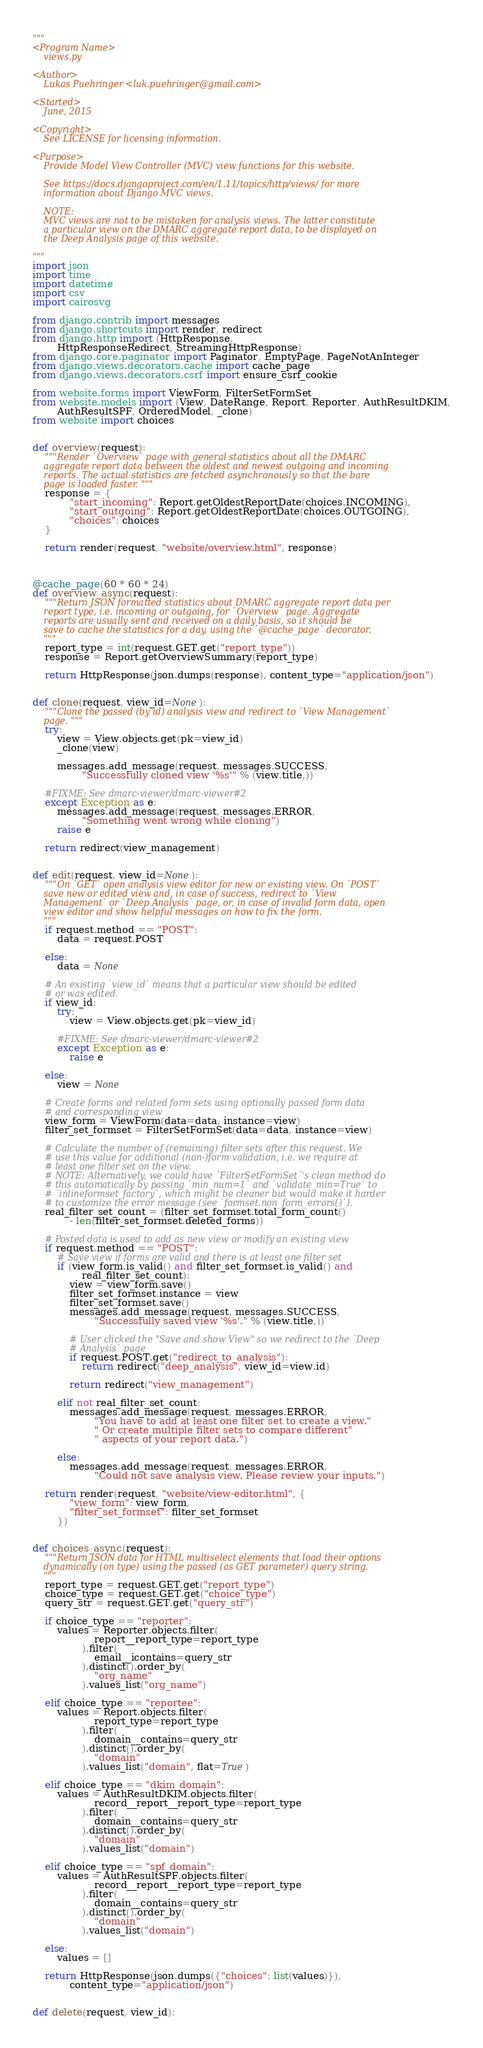<code> <loc_0><loc_0><loc_500><loc_500><_Python_>"""
<Program Name>
    views.py

<Author>
    Lukas Puehringer <luk.puehringer@gmail.com>

<Started>
    June, 2015

<Copyright>
    See LICENSE for licensing information.

<Purpose>
    Provide Model View Controller (MVC) view functions for this website.

    See https://docs.djangoproject.com/en/1.11/topics/http/views/ for more
    information about Django MVC views.

    NOTE:
    MVC views are not to be mistaken for analysis views. The latter constitute
    a particular view on the DMARC aggregate report data, to be displayed on
    the Deep Analysis page of this website.

"""
import json
import time
import datetime
import csv
import cairosvg

from django.contrib import messages
from django.shortcuts import render, redirect
from django.http import (HttpResponse,
        HttpResponseRedirect, StreamingHttpResponse)
from django.core.paginator import Paginator, EmptyPage, PageNotAnInteger
from django.views.decorators.cache import cache_page
from django.views.decorators.csrf import ensure_csrf_cookie

from website.forms import ViewForm, FilterSetFormSet
from website.models import (View, DateRange, Report, Reporter, AuthResultDKIM,
        AuthResultSPF, OrderedModel, _clone)
from website import choices


def overview(request):
    """Render `Overview` page with general statistics about all the DMARC
    aggregate report data between the oldest and newest outgoing and incoming
    reports. The actual statistics are fetched asynchronously so that the bare
    page is loaded faster. """
    response = {
            "start_incoming": Report.getOldestReportDate(choices.INCOMING),
            "start_outgoing": Report.getOldestReportDate(choices.OUTGOING),
            "choices": choices
    }

    return render(request, "website/overview.html", response)



@cache_page(60 * 60 * 24)
def overview_async(request):
    """Return JSON formatted statistics about DMARC aggregate report data per
    report type, i.e. incoming or outgoing, for `Overview` page. Aggregate
    reports are usually sent and received on a daily basis, so it should be
    save to cache the statistics for a day, using the `@cache_page` decorator.
    """
    report_type = int(request.GET.get("report_type"))
    response = Report.getOverviewSummary(report_type)

    return HttpResponse(json.dumps(response), content_type="application/json")


def clone(request, view_id=None):
    """Clone the passed (by id) analysis view and redirect to `View Management`
    page. """
    try:
        view = View.objects.get(pk=view_id)
        _clone(view)

        messages.add_message(request, messages.SUCCESS,
                "Successfully cloned view '%s'" % (view.title,))

    #FIXME: See dmarc-viewer/dmarc-viewer#2
    except Exception as e:
        messages.add_message(request, messages.ERROR,
                "Something went wrong while cloning")
        raise e

    return redirect(view_management)


def edit(request, view_id=None):
    """On `GET` open analysis view editor for new or existing view. On `POST`
    save new or edited view and, in case of success, redirect to `View
    Management` or `Deep Analysis` page, or, in case of invalid form data, open
    view editor and show helpful messages on how to fix the form.
    """
    if request.method == "POST":
        data = request.POST

    else:
        data = None

    # An existing `view_id` means that a particular view should be edited
    # or was edited.
    if view_id:
        try:
            view = View.objects.get(pk=view_id)

        #FIXME: See dmarc-viewer/dmarc-viewer#2
        except Exception as e:
            raise e

    else:
        view = None

    # Create forms and related form sets using optionally passed form data
    # and corresponding view
    view_form = ViewForm(data=data, instance=view)
    filter_set_formset = FilterSetFormSet(data=data, instance=view)

    # Calculate the number of (remaining) filter sets after this request. We
    # use this value for additional (non-)form validation, i.e. we require at
    # least one filter set on the view.
    # NOTE: Alternatively, we could have `FilterSetFormSet`'s clean method do
    # this automatically by passing `min_num=1` and `validate_min=True` to
    # `inlineformset_factory`, which might be cleaner but would make it harder
    # to customize the error message (see `formset.non_form_errors()`).
    real_filter_set_count = (filter_set_formset.total_form_count()
            - len(filter_set_formset.deleted_forms))

    # Posted data is used to add as new view or modify an existing view
    if request.method == "POST":
        # Save view if forms are valid and there is at least one filter set
        if (view_form.is_valid() and filter_set_formset.is_valid() and
                real_filter_set_count):
            view = view_form.save()
            filter_set_formset.instance = view
            filter_set_formset.save()
            messages.add_message(request, messages.SUCCESS,
                    "Successfully saved view '%s'." % (view.title,))

            # User clicked the "Save and show View" so we redirect to the `Deep
            # Analysis` page
            if request.POST.get("redirect_to_analysis"):
                return redirect("deep_analysis", view_id=view.id)

            return redirect("view_management")

        elif not real_filter_set_count:
            messages.add_message(request, messages.ERROR,
                    "You have to add at least one filter set to create a view."
                    " Or create multiple filter sets to compare different"
                    " aspects of your report data.")

        else:
            messages.add_message(request, messages.ERROR,
                    "Could not save analysis view. Please review your inputs.")

    return render(request, "website/view-editor.html", {
            "view_form": view_form,
            "filter_set_formset": filter_set_formset
        })


def choices_async(request):
    """Return JSON data for HTML multiselect elements that load their options
    dynamically (on type) using the passed (as GET parameter) query string.
    """
    report_type = request.GET.get("report_type")
    choice_type = request.GET.get("choice_type")
    query_str = request.GET.get("query_str")

    if choice_type == "reporter":
        values = Reporter.objects.filter(
                    report__report_type=report_type
                ).filter(
                    email__icontains=query_str
                ).distinct().order_by(
                    "org_name"
                ).values_list("org_name")

    elif choice_type == "reportee":
        values = Report.objects.filter(
                    report_type=report_type
                ).filter(
                    domain__contains=query_str
                ).distinct().order_by(
                    "domain"
                ).values_list("domain", flat=True)

    elif choice_type == "dkim_domain":
        values = AuthResultDKIM.objects.filter(
                    record__report__report_type=report_type
                ).filter(
                    domain__contains=query_str
                ).distinct().order_by(
                    "domain"
                ).values_list("domain")

    elif choice_type == "spf_domain":
        values = AuthResultSPF.objects.filter(
                    record__report__report_type=report_type
                ).filter(
                    domain__contains=query_str
                ).distinct().order_by(
                    "domain"
                ).values_list("domain")

    else:
        values = []

    return HttpResponse(json.dumps({"choices": list(values)}),
            content_type="application/json")


def delete(request, view_id):</code> 